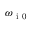Convert formula to latex. <formula><loc_0><loc_0><loc_500><loc_500>\omega _ { i 0 }</formula> 